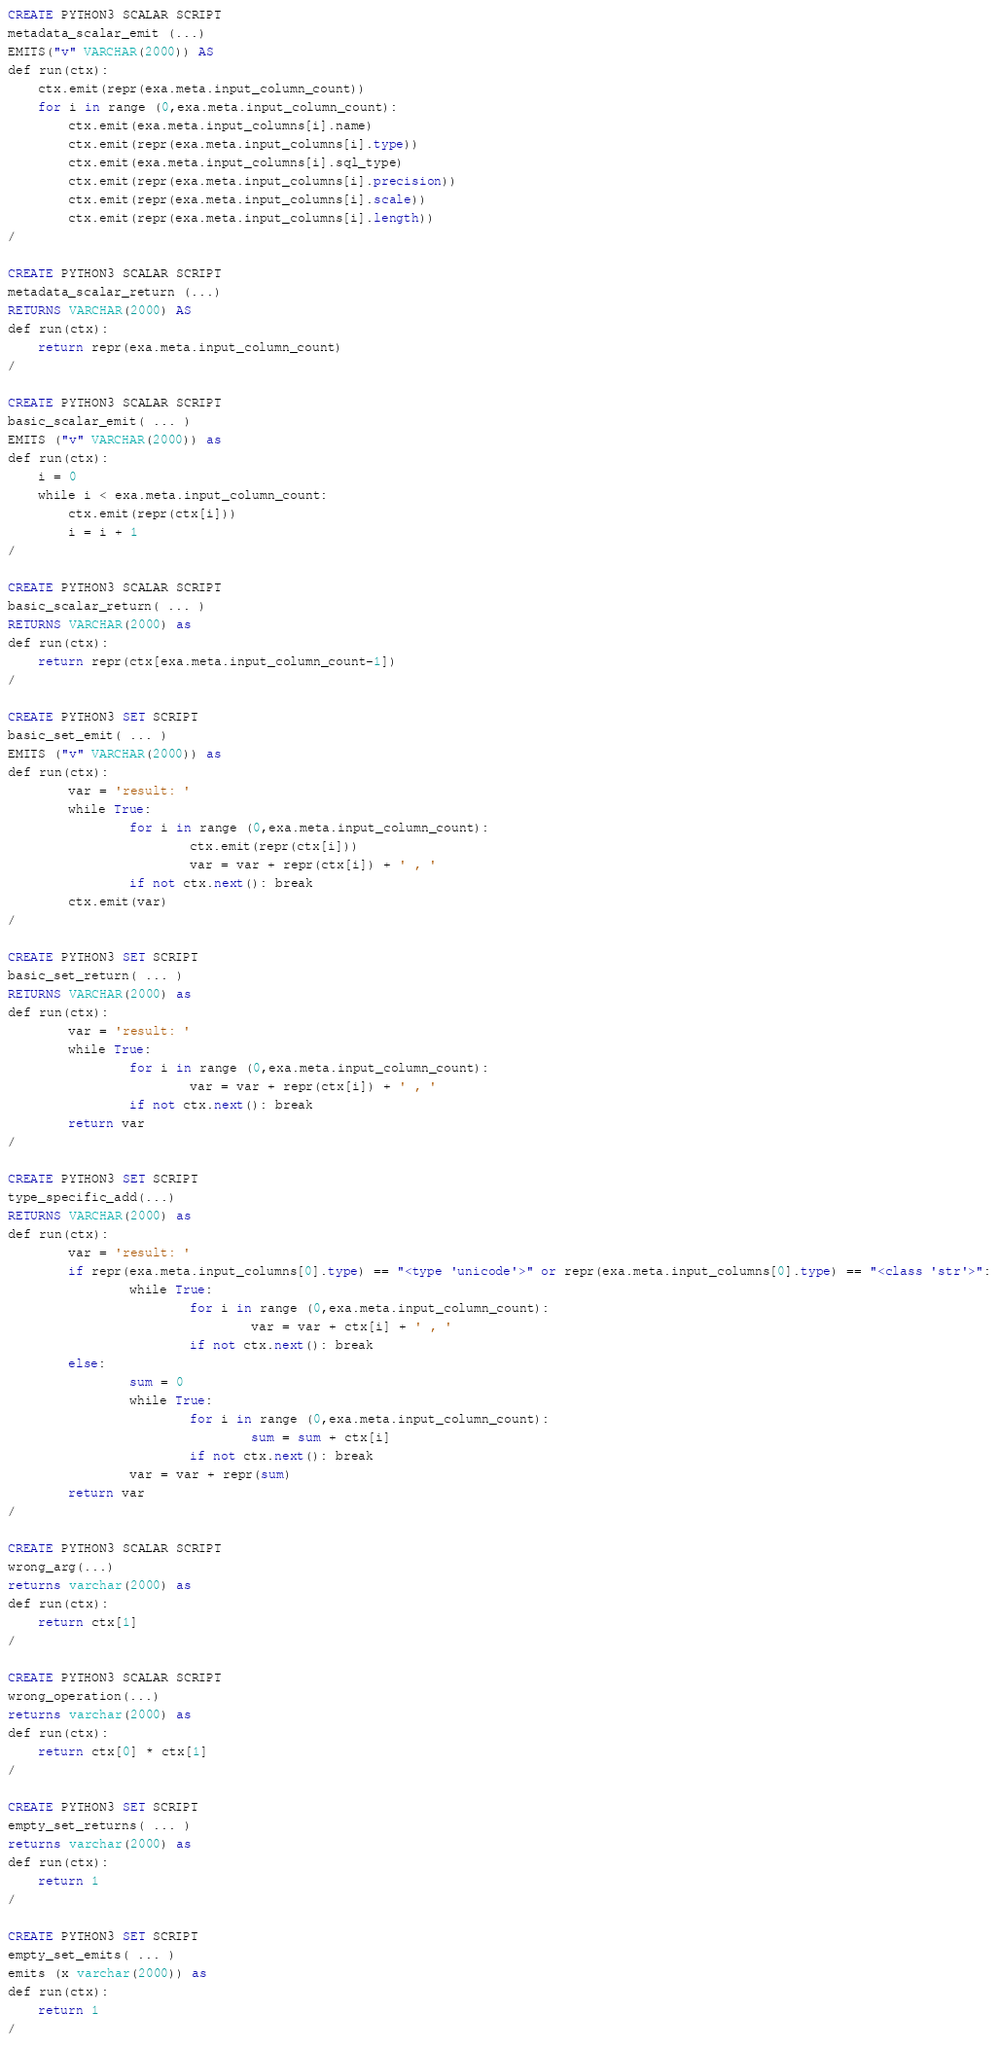<code> <loc_0><loc_0><loc_500><loc_500><_SQL_>CREATE PYTHON3 SCALAR SCRIPT
metadata_scalar_emit (...)
EMITS("v" VARCHAR(2000)) AS
def run(ctx):
    ctx.emit(repr(exa.meta.input_column_count))
    for i in range (0,exa.meta.input_column_count):
        ctx.emit(exa.meta.input_columns[i].name)
        ctx.emit(repr(exa.meta.input_columns[i].type))
        ctx.emit(exa.meta.input_columns[i].sql_type)
        ctx.emit(repr(exa.meta.input_columns[i].precision))
        ctx.emit(repr(exa.meta.input_columns[i].scale))
        ctx.emit(repr(exa.meta.input_columns[i].length))
/

CREATE PYTHON3 SCALAR SCRIPT
metadata_scalar_return (...)
RETURNS VARCHAR(2000) AS
def run(ctx):
    return repr(exa.meta.input_column_count)
/

CREATE PYTHON3 SCALAR SCRIPT
basic_scalar_emit( ... )
EMITS ("v" VARCHAR(2000)) as
def run(ctx):
    i = 0
    while i < exa.meta.input_column_count:
        ctx.emit(repr(ctx[i]))
        i = i + 1
/

CREATE PYTHON3 SCALAR SCRIPT
basic_scalar_return( ... )
RETURNS VARCHAR(2000) as
def run(ctx):
    return repr(ctx[exa.meta.input_column_count-1])
/

CREATE PYTHON3 SET SCRIPT
basic_set_emit( ... )
EMITS ("v" VARCHAR(2000)) as
def run(ctx):
        var = 'result: '
        while True:
                for i in range (0,exa.meta.input_column_count):
                        ctx.emit(repr(ctx[i]))
                        var = var + repr(ctx[i]) + ' , '
                if not ctx.next(): break
        ctx.emit(var)
/

CREATE PYTHON3 SET SCRIPT
basic_set_return( ... )
RETURNS VARCHAR(2000) as
def run(ctx):
        var = 'result: '
        while True:
                for i in range (0,exa.meta.input_column_count):
                        var = var + repr(ctx[i]) + ' , '
                if not ctx.next(): break
        return var
/

CREATE PYTHON3 SET SCRIPT
type_specific_add(...)
RETURNS VARCHAR(2000) as
def run(ctx):
        var = 'result: '
        if repr(exa.meta.input_columns[0].type) == "<type 'unicode'>" or repr(exa.meta.input_columns[0].type) == "<class 'str'>":
                while True:
                        for i in range (0,exa.meta.input_column_count):
                                var = var + ctx[i] + ' , '
                        if not ctx.next(): break
        else:
                sum = 0
                while True:
                        for i in range (0,exa.meta.input_column_count):
                                sum = sum + ctx[i]
                        if not ctx.next(): break
                var = var + repr(sum)
        return var
/

CREATE PYTHON3 SCALAR SCRIPT
wrong_arg(...)
returns varchar(2000) as
def run(ctx):
    return ctx[1]
/

CREATE PYTHON3 SCALAR SCRIPT
wrong_operation(...)
returns varchar(2000) as
def run(ctx):
    return ctx[0] * ctx[1]
/

CREATE PYTHON3 SET SCRIPT
empty_set_returns( ... )
returns varchar(2000) as
def run(ctx):
    return 1
/

CREATE PYTHON3 SET SCRIPT
empty_set_emits( ... )
emits (x varchar(2000)) as
def run(ctx):
    return 1
/
</code> 